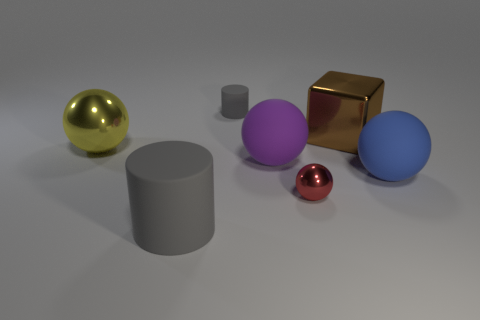There is a big gray object that is made of the same material as the blue object; what is its shape?
Ensure brevity in your answer.  Cylinder. The gray object that is the same material as the big cylinder is what size?
Your answer should be very brief. Small. What is the shape of the thing that is on the right side of the small gray matte cylinder and in front of the big blue matte thing?
Your answer should be very brief. Sphere. There is a matte cylinder that is on the left side of the gray rubber thing that is behind the yellow shiny sphere; what size is it?
Ensure brevity in your answer.  Large. How many other things are the same color as the tiny rubber thing?
Keep it short and to the point. 1. What material is the big gray cylinder?
Offer a very short reply. Rubber. Are any small brown rubber cubes visible?
Ensure brevity in your answer.  No. Are there an equal number of gray cylinders behind the small red metal thing and small blue spheres?
Your answer should be very brief. No. Is there anything else that is the same material as the large gray object?
Your response must be concise. Yes. What number of large objects are metal blocks or blue rubber balls?
Your answer should be very brief. 2. 